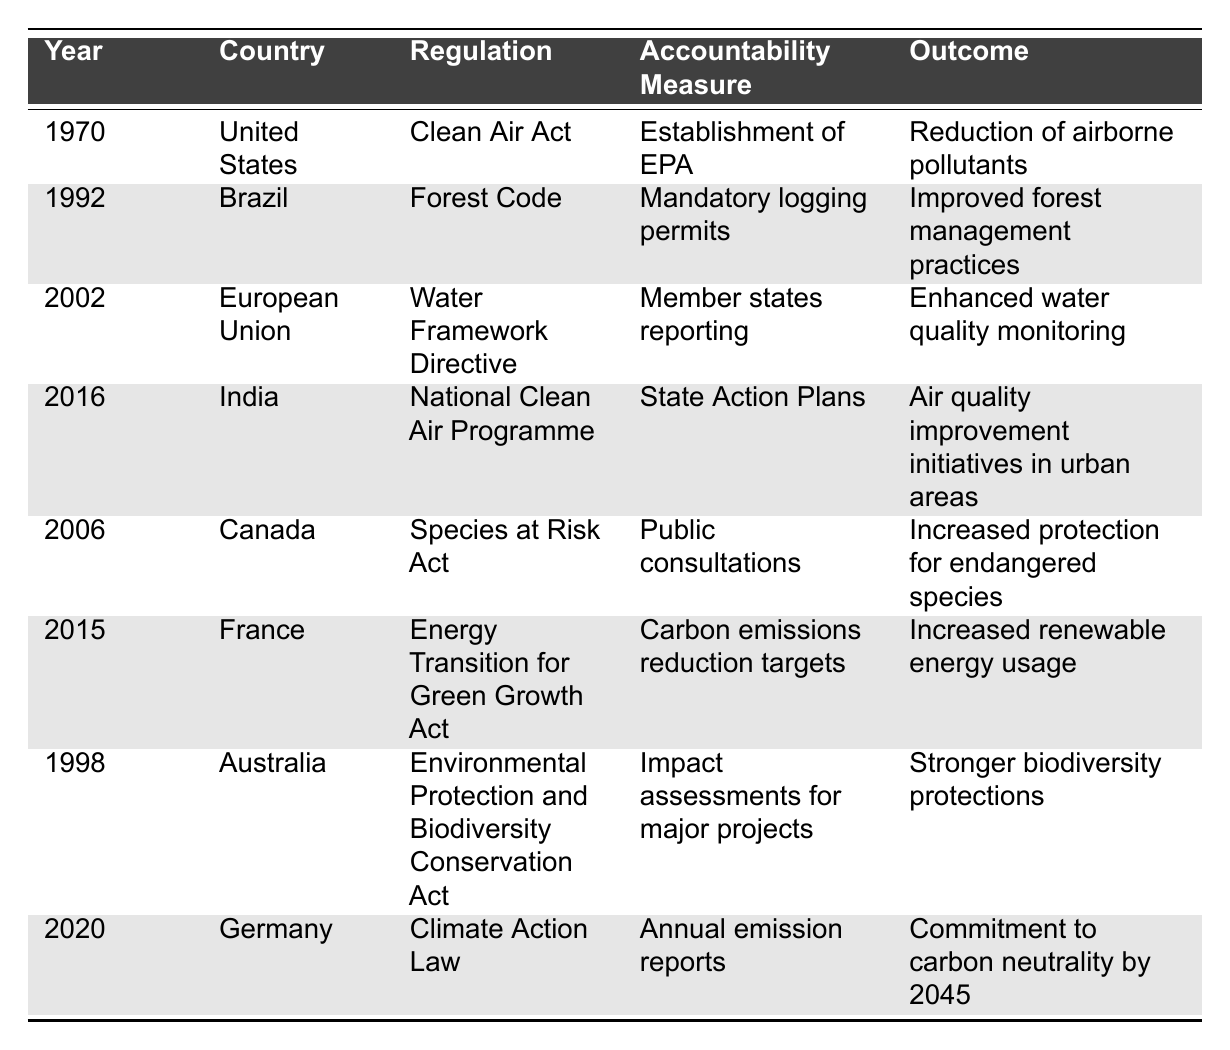What was the first environmental regulation listed in the table? The table shows the "Clean Air Act" as the regulation for the year 1970, which is the earliest year in the data.
Answer: Clean Air Act Which country implemented an accountability measure involving mandatory logging permits? Brazil is listed with the Forest Code and the accountability measure of mandatory logging permits in 1992.
Answer: Brazil How many regulations focused on air quality improvement are mentioned in the table? The table lists two regulations related to air quality: the Clean Air Act in 1970 and the National Clean Air Programme in 2016.
Answer: 2 Did any regulation come after 2015 to emphasize accountability in environmental protection? Yes, the Climate Action Law from Germany in 2020 is mentioned in the table, which emphasizes accountability through annual emission reports.
Answer: Yes What is the common accountability measure used in both the United States and Germany? The accountability measure in the United States is the establishment of the EPA for the Clean Air Act, while in Germany, the Climate Action Law requires annual emission reports, focusing on governmental oversight. However, they differ as they don't share a common accountability measure directly.
Answer: No Which regulation resulted in stronger biodiversity protections? The Environmental Protection and Biodiversity Conservation Act in Australia, enacted in 1998, is associated with stronger biodiversity protections through its accountability measure of impact assessments for major projects.
Answer: Environmental Protection and Biodiversity Conservation Act What is the outcome of the Energy Transition for Green Growth Act in France? The outcome listed for this regulation is the increased renewable energy usage attributed to carbon emissions reduction targets.
Answer: Increased renewable energy usage In which year did Canada establish public consultations as an accountability measure? The Species at Risk Act in Canada used public consultations as an accountability measure in 2006.
Answer: 2006 What is the latest regulation listed that aims for carbon neutrality? The latest regulation aimed at carbon neutrality is Germany's Climate Action Law from 2020, which commits to carbon neutrality by 2045.
Answer: Climate Action Law How many years separate the Clean Air Act and the Water Framework Directive? The Clean Air Act was established in 1970, and the Water Framework Directive was established in 2002, which is a difference of 32 years.
Answer: 32 years Can we say that India initiated a plan to improve air quality before any European regulation? Yes, the National Clean Air Programme in India was introduced in 2016, while the earliest European regulation listed, the Water Framework Directive, came in 2002. Thus, India acted after but not before by comparison to the overall table.
Answer: No 